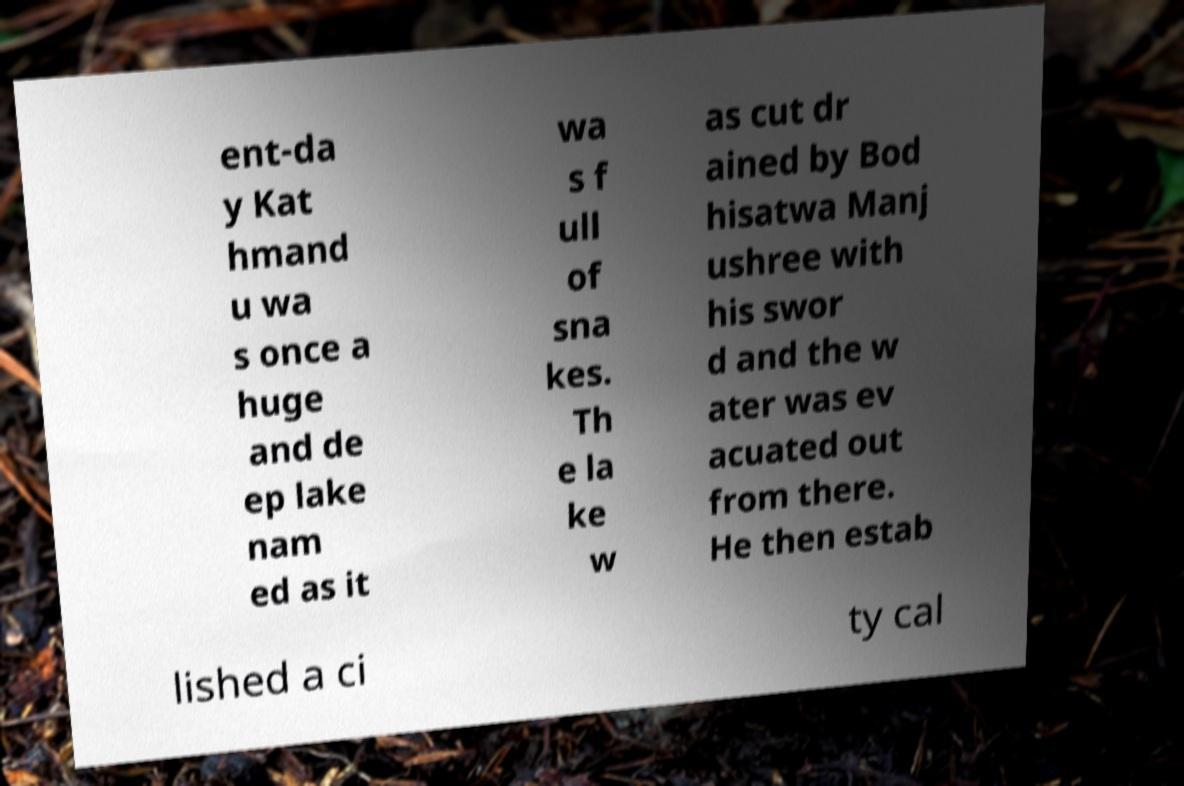There's text embedded in this image that I need extracted. Can you transcribe it verbatim? ent-da y Kat hmand u wa s once a huge and de ep lake nam ed as it wa s f ull of sna kes. Th e la ke w as cut dr ained by Bod hisatwa Manj ushree with his swor d and the w ater was ev acuated out from there. He then estab lished a ci ty cal 